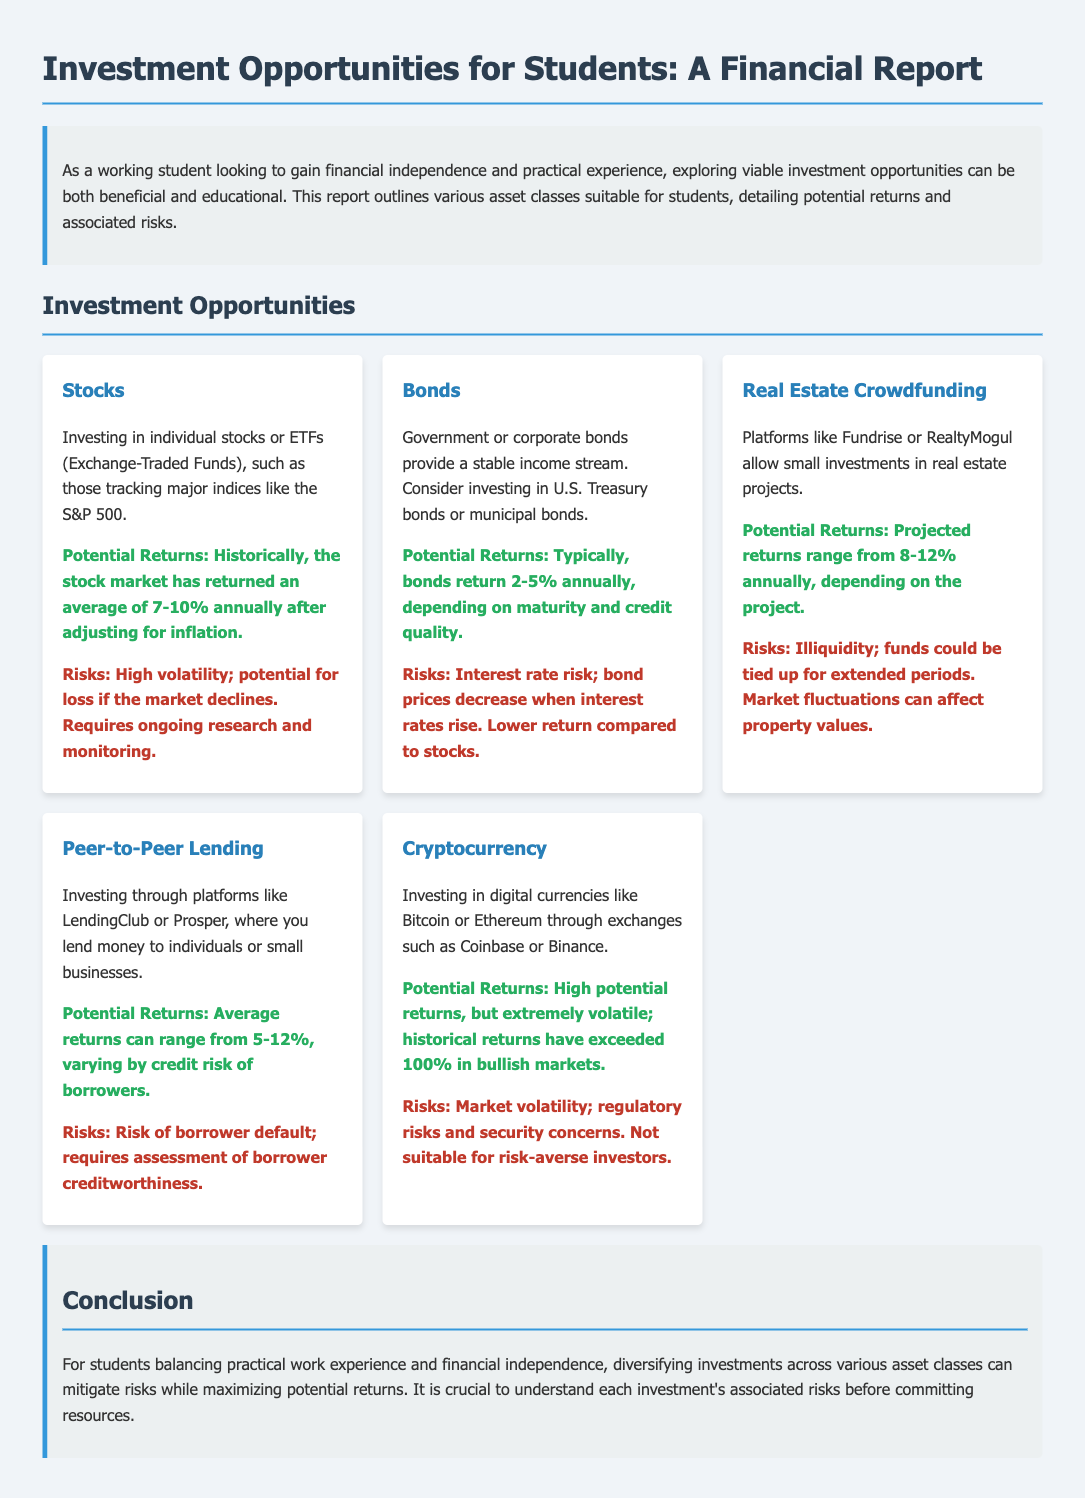What are the potential returns for stocks? The potential returns for stocks are historically around 7-10% annually after adjusting for inflation.
Answer: 7-10% What is the primary risk associated with bonds? The primary risk associated with bonds is interest rate risk; bond prices decrease when interest rates rise.
Answer: Interest rate risk What is the potential return for real estate crowdfunding? The potential return for real estate crowdfunding projects ranges from 8-12% annually, depending on the project.
Answer: 8-12% Which investment class involves lending money to individuals or small businesses? The investment class that involves lending money to individuals or small businesses is Peer-to-Peer Lending.
Answer: Peer-to-Peer Lending What is the theme of the conclusion? The theme of the conclusion emphasizes diversifying investments across various asset classes to mitigate risks while maximizing potential returns.
Answer: Diversifying investments What is one notable characteristic of cryptocurrency investments? One notable characteristic of cryptocurrency investments is that they are extremely volatile; historical returns have exceeded 100% in bullish markets.
Answer: Extremely volatile What type of report is this document? This document is a financial report about investment opportunities suitable for students.
Answer: Financial report What are the average returns from peer-to-peer lending? The average returns from peer-to-peer lending can range from 5-12%, varying by credit risk of borrowers.
Answer: 5-12% 